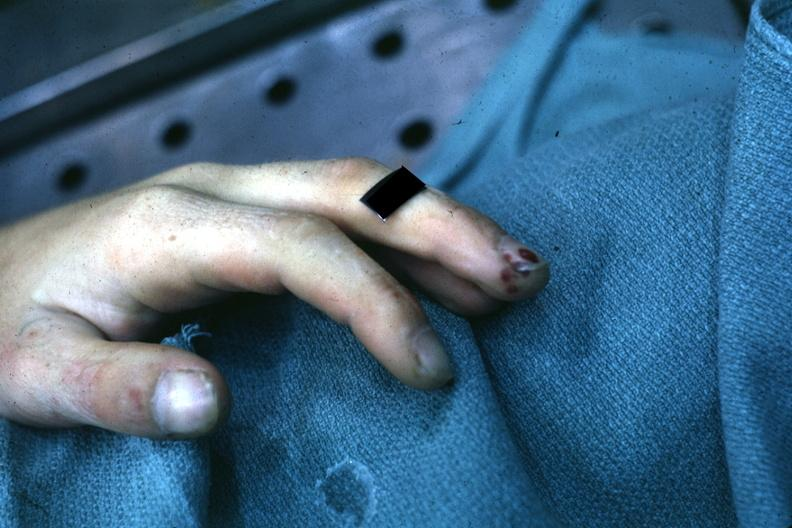does close-up tumor show very good example of focal necrotizing lesions in distal portion of digit associated with bacterial endocarditis?
Answer the question using a single word or phrase. No 